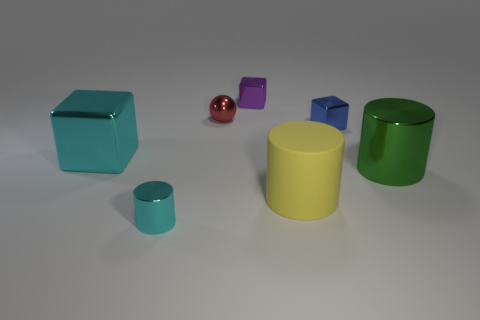How big is the cyan thing on the right side of the cyan object behind the big object that is right of the yellow cylinder? It appears to be a small cyan cube, significantly smaller in size compared to the larger cyan cube situated on its left. 